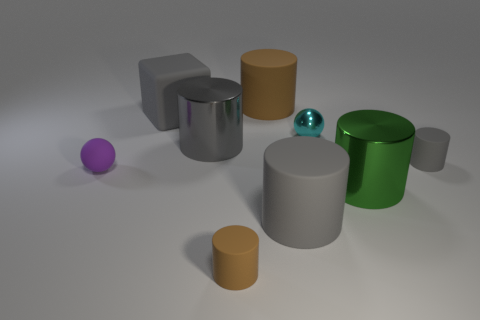Subtract all gray spheres. How many gray cylinders are left? 3 Subtract all tiny gray rubber cylinders. How many cylinders are left? 5 Subtract all brown cylinders. How many cylinders are left? 4 Subtract all blue cylinders. Subtract all red balls. How many cylinders are left? 6 Subtract all blocks. How many objects are left? 8 Add 5 matte cylinders. How many matte cylinders exist? 9 Subtract 0 red cylinders. How many objects are left? 9 Subtract all tiny rubber cylinders. Subtract all small matte spheres. How many objects are left? 6 Add 1 big brown things. How many big brown things are left? 2 